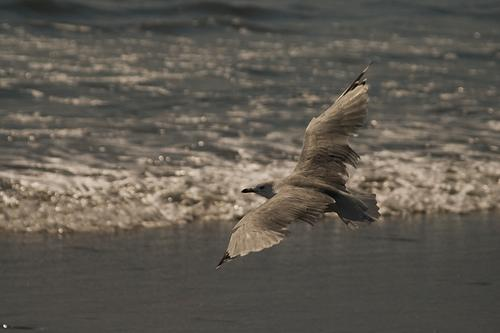Compose a haiku inspired by the image. Nature's dance unfolds. With a journalistic approach, summarize what is happening in the image. Seagull spotted soaring over ocean, while waves crash ashore, painting a picturesque scene for beachgoers. In a poetic way, describe the main subject and the environment in the image. A graceful bird takes to the sky, its wings unfurled; below it lies the glistening ocean, where waves caress the sandy shore. Provide a brief overview of the image using words suitable for a children's story. One sunny day, a friendly seagull spread its wings wide and flew over the sparkling water and sandy beach, where children laughed and played. Describe the main event occurring in the image using alliteration. A brilliant bird boldly braves the breeze, blissfully breezing by the beautiful beach below. Craft a short story opening based on the scene captured in the image. Once upon a time, on a sunny day by the beach, a seagull with outstretched wings soared high above the crashing waves, searching for its next meal. Explain what the animal in the image is doing using scientific terminology. An avian species, likely Larus argentatus, exhibits a soaring flight pattern over a littoral zone characterized by visible wave patterns. Write a sentence describing the main elements in the image using an informal tone. OMG! Check out this awesome pic of a seagull flying right over the waves at the beach! So cool! Mention the most prominent feature of the image and a brief action it's performing. A flying bird with outstretched wings soaring over a beach with rippling waves. Concisely describe the focal point of the image in a casual manner. There's this white bird in flight above the ocean, with its wings all stretched out. 